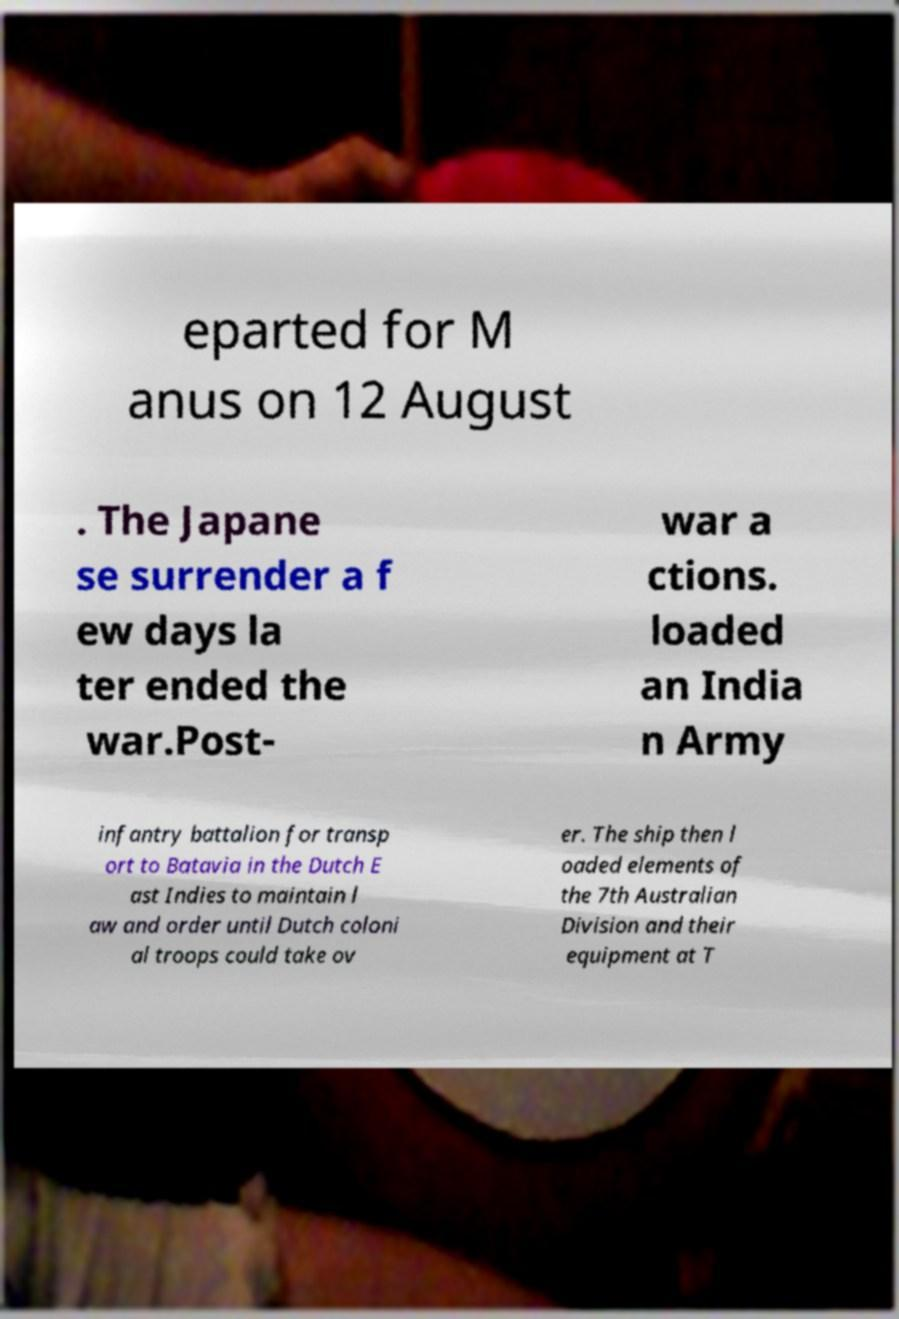I need the written content from this picture converted into text. Can you do that? eparted for M anus on 12 August . The Japane se surrender a f ew days la ter ended the war.Post- war a ctions. loaded an India n Army infantry battalion for transp ort to Batavia in the Dutch E ast Indies to maintain l aw and order until Dutch coloni al troops could take ov er. The ship then l oaded elements of the 7th Australian Division and their equipment at T 